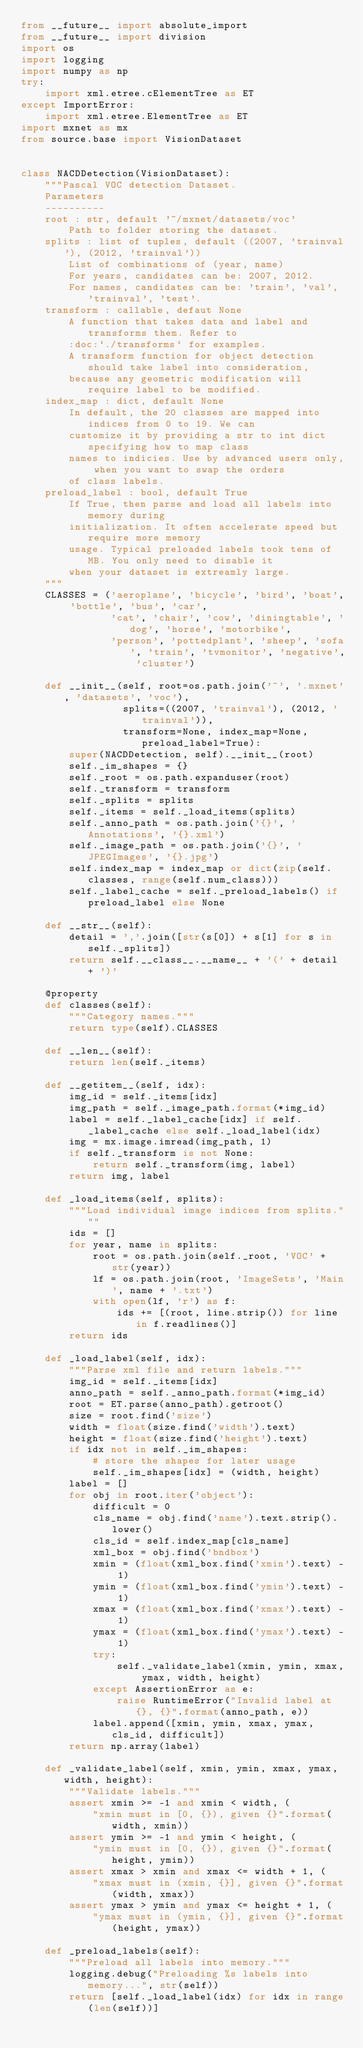Convert code to text. <code><loc_0><loc_0><loc_500><loc_500><_Python_>from __future__ import absolute_import
from __future__ import division
import os
import logging
import numpy as np
try:
    import xml.etree.cElementTree as ET
except ImportError:
    import xml.etree.ElementTree as ET
import mxnet as mx
from source.base import VisionDataset


class NACDDetection(VisionDataset):
    """Pascal VOC detection Dataset.
    Parameters
    ----------
    root : str, default '~/mxnet/datasets/voc'
        Path to folder storing the dataset.
    splits : list of tuples, default ((2007, 'trainval'), (2012, 'trainval'))
        List of combinations of (year, name)
        For years, candidates can be: 2007, 2012.
        For names, candidates can be: 'train', 'val', 'trainval', 'test'.
    transform : callable, defaut None
        A function that takes data and label and transforms them. Refer to
        :doc:`./transforms` for examples.
        A transform function for object detection should take label into consideration,
        because any geometric modification will require label to be modified.
    index_map : dict, default None
        In default, the 20 classes are mapped into indices from 0 to 19. We can
        customize it by providing a str to int dict specifying how to map class
        names to indicies. Use by advanced users only, when you want to swap the orders
        of class labels.
    preload_label : bool, default True
        If True, then parse and load all labels into memory during
        initialization. It often accelerate speed but require more memory
        usage. Typical preloaded labels took tens of MB. You only need to disable it
        when your dataset is extreamly large.
    """
    CLASSES = ('aeroplane', 'bicycle', 'bird', 'boat', 'bottle', 'bus', 'car',
               'cat', 'chair', 'cow', 'diningtable', 'dog', 'horse', 'motorbike',
               'person', 'pottedplant', 'sheep', 'sofa', 'train', 'tvmonitor', 'negative', 'cluster')

    def __init__(self, root=os.path.join('~', '.mxnet', 'datasets', 'voc'),
                 splits=((2007, 'trainval'), (2012, 'trainval')),
                 transform=None, index_map=None, preload_label=True):
        super(NACDDetection, self).__init__(root)
        self._im_shapes = {}
        self._root = os.path.expanduser(root)
        self._transform = transform
        self._splits = splits
        self._items = self._load_items(splits)
        self._anno_path = os.path.join('{}', 'Annotations', '{}.xml')
        self._image_path = os.path.join('{}', 'JPEGImages', '{}.jpg')
        self.index_map = index_map or dict(zip(self.classes, range(self.num_class)))
        self._label_cache = self._preload_labels() if preload_label else None

    def __str__(self):
        detail = ','.join([str(s[0]) + s[1] for s in self._splits])
        return self.__class__.__name__ + '(' + detail + ')'

    @property
    def classes(self):
        """Category names."""
        return type(self).CLASSES

    def __len__(self):
        return len(self._items)

    def __getitem__(self, idx):
        img_id = self._items[idx]
        img_path = self._image_path.format(*img_id)
        label = self._label_cache[idx] if self._label_cache else self._load_label(idx)
        img = mx.image.imread(img_path, 1)
        if self._transform is not None:
            return self._transform(img, label)
        return img, label

    def _load_items(self, splits):
        """Load individual image indices from splits."""
        ids = []
        for year, name in splits:
            root = os.path.join(self._root, 'VOC' + str(year))
            lf = os.path.join(root, 'ImageSets', 'Main', name + '.txt')
            with open(lf, 'r') as f:
                ids += [(root, line.strip()) for line in f.readlines()]
        return ids

    def _load_label(self, idx):
        """Parse xml file and return labels."""
        img_id = self._items[idx]
        anno_path = self._anno_path.format(*img_id)
        root = ET.parse(anno_path).getroot()
        size = root.find('size')
        width = float(size.find('width').text)
        height = float(size.find('height').text)
        if idx not in self._im_shapes:
            # store the shapes for later usage
            self._im_shapes[idx] = (width, height)
        label = []
        for obj in root.iter('object'):
            difficult = 0
            cls_name = obj.find('name').text.strip().lower()
            cls_id = self.index_map[cls_name]
            xml_box = obj.find('bndbox')
            xmin = (float(xml_box.find('xmin').text) - 1)
            ymin = (float(xml_box.find('ymin').text) - 1)
            xmax = (float(xml_box.find('xmax').text) - 1)
            ymax = (float(xml_box.find('ymax').text) - 1)
            try:
                self._validate_label(xmin, ymin, xmax, ymax, width, height)
            except AssertionError as e:
                raise RuntimeError("Invalid label at {}, {}".format(anno_path, e))
            label.append([xmin, ymin, xmax, ymax, cls_id, difficult])
        return np.array(label)

    def _validate_label(self, xmin, ymin, xmax, ymax, width, height):
        """Validate labels."""
        assert xmin >= -1 and xmin < width, (
            "xmin must in [0, {}), given {}".format(width, xmin))
        assert ymin >= -1 and ymin < height, (
            "ymin must in [0, {}), given {}".format(height, ymin))
        assert xmax > xmin and xmax <= width + 1, (
            "xmax must in (xmin, {}], given {}".format(width, xmax))
        assert ymax > ymin and ymax <= height + 1, (
            "ymax must in (ymin, {}], given {}".format(height, ymax))

    def _preload_labels(self):
        """Preload all labels into memory."""
        logging.debug("Preloading %s labels into memory...", str(self))
        return [self._load_label(idx) for idx in range(len(self))]
</code> 